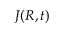<formula> <loc_0><loc_0><loc_500><loc_500>J ( R , t )</formula> 